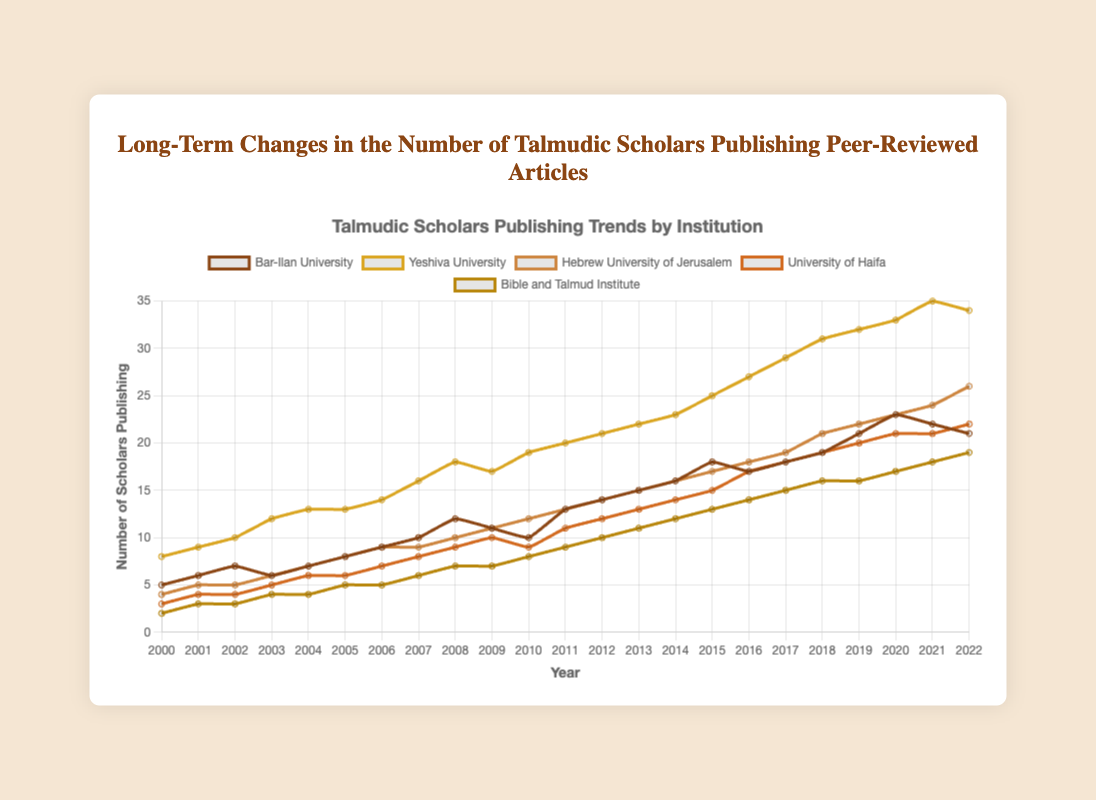Which institution had the highest number of publishing scholars in 2022? To answer this question, look at the ending points of all the line plots on the far right side of the chart for the year 2022. Compare the values for each institution.
Answer: Yeshiva University How many more scholars published from Yeshiva University than from Bible and Talmud Institute in 2022? Locate the number of publishing scholars for Yeshiva University and the Bible and Talmud Institute in 2022. Subtract the number of publishing scholars from the Bible and Talmud Institute from Yeshiva University's number. (34 - 19)
Answer: 15 During which year did Bar-Ilan University see the largest increase in the number of publishing scholars? Identify the years by examining the line representing Bar-Ilan University. Look for the year-by-year differences and determine the year with the largest positive change.
Answer: 2010 to 2011 Which institution showed the most consistent growth in the number of publishing scholars from 2000 to 2022? Observe the trends in each line chart. Consistent growth would be indicated by a smooth, upward-sloping line without large fluctuations. The Hebrew University of Jerusalem shows a steady continuous increase.
Answer: Hebrew University of Jerusalem Compare the number of publishing scholars at Bar-Ilan University in 2000 and the peak year. By how much did the number increase? Find the number of scholars publishing in the year 2000 for Bar-Ilan University and locate the peak year value. Subtract the 2000 value from the peak year value. (23 - 5)
Answer: 18 What is the total number of publishing scholars from University of Haifa over the data period 2000 to 2022? Add the number of scholars publishing for each year from 2000 to 2022 for the University of Haifa. (3 + 4 + 4 + 5 + 6 + 6 + 7 + 8 + 9 + 10 + 9 + 11 + 12 + 13 + 14 + 15 + 17 + 18 + 19 + 20 + 21 + 21 + 22)
Answer: 275 Between which two consecutive years did Yeshiva University experience the highest increase in the number of publishing scholars? Examine the annual increments in the Yeshiva University data series. Identify the two consecutive years with the largest increase. The largest increment occurs between 2014 and 2015.
Answer: 2014 and 2015 What is the average increase per year in the number of publishing scholars for the Bible and Talmud Institute from 2000 to 2022? Calculate the total increase from 2000 to 2022 by subtracting the number of publishing scholars in 2000 from that in 2022. Divide this total increase by the number of years (2022 - 2000). ((19 - 2) / (2022 - 2000))
Answer: 0.772 